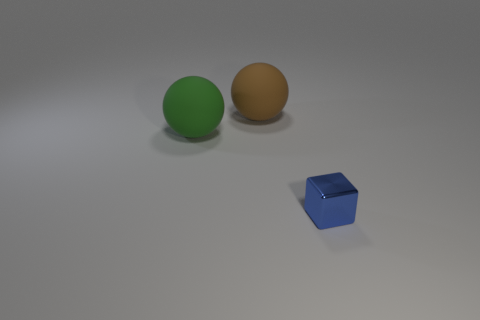Are the sphere that is left of the brown rubber object and the sphere that is behind the big green matte ball made of the same material?
Keep it short and to the point. Yes. Is there any other thing that is the same shape as the small metal thing?
Keep it short and to the point. No. What number of other large rubber objects have the same shape as the big green thing?
Give a very brief answer. 1. There is another rubber ball that is the same size as the brown ball; what color is it?
Provide a short and direct response. Green. Is there a large red matte block?
Ensure brevity in your answer.  No. What shape is the large thing in front of the brown rubber ball?
Give a very brief answer. Sphere. How many things are on the left side of the shiny block and right of the large green object?
Offer a very short reply. 1. Are there any small brown spheres made of the same material as the blue block?
Ensure brevity in your answer.  No. How many balls are either large brown things or green things?
Provide a short and direct response. 2. The brown matte thing has what size?
Ensure brevity in your answer.  Large. 